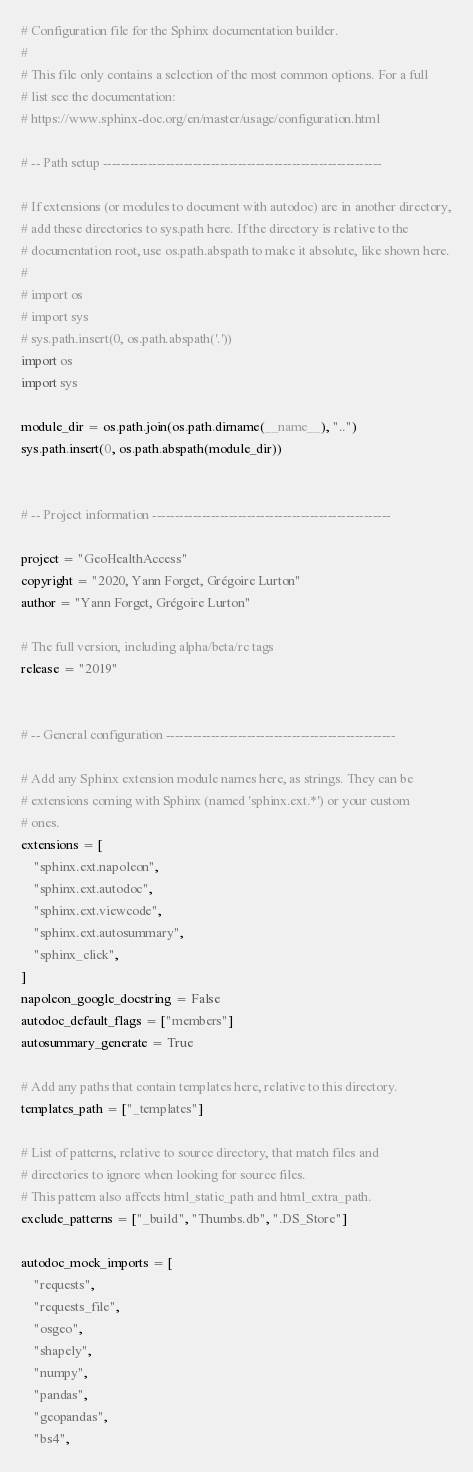Convert code to text. <code><loc_0><loc_0><loc_500><loc_500><_Python_># Configuration file for the Sphinx documentation builder.
#
# This file only contains a selection of the most common options. For a full
# list see the documentation:
# https://www.sphinx-doc.org/en/master/usage/configuration.html

# -- Path setup --------------------------------------------------------------

# If extensions (or modules to document with autodoc) are in another directory,
# add these directories to sys.path here. If the directory is relative to the
# documentation root, use os.path.abspath to make it absolute, like shown here.
#
# import os
# import sys
# sys.path.insert(0, os.path.abspath('.'))
import os
import sys

module_dir = os.path.join(os.path.dirname(__name__), "..")
sys.path.insert(0, os.path.abspath(module_dir))


# -- Project information -----------------------------------------------------

project = "GeoHealthAccess"
copyright = "2020, Yann Forget, Grégoire Lurton"
author = "Yann Forget, Grégoire Lurton"

# The full version, including alpha/beta/rc tags
release = "2019"


# -- General configuration ---------------------------------------------------

# Add any Sphinx extension module names here, as strings. They can be
# extensions coming with Sphinx (named 'sphinx.ext.*') or your custom
# ones.
extensions = [
    "sphinx.ext.napoleon",
    "sphinx.ext.autodoc",
    "sphinx.ext.viewcode",
    "sphinx.ext.autosummary",
    "sphinx_click",
]
napoleon_google_docstring = False
autodoc_default_flags = ["members"]
autosummary_generate = True

# Add any paths that contain templates here, relative to this directory.
templates_path = ["_templates"]

# List of patterns, relative to source directory, that match files and
# directories to ignore when looking for source files.
# This pattern also affects html_static_path and html_extra_path.
exclude_patterns = ["_build", "Thumbs.db", ".DS_Store"]

autodoc_mock_imports = [
    "requests",
    "requests_file",
    "osgeo",
    "shapely",
    "numpy",
    "pandas",
    "geopandas",
    "bs4",</code> 